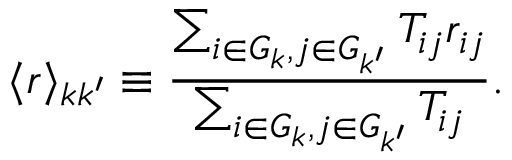Convert formula to latex. <formula><loc_0><loc_0><loc_500><loc_500>\langle r \rangle _ { k k ^ { \prime } } \equiv \frac { \sum _ { i \in G _ { k } , j \in G _ { k ^ { \prime } } } { T _ { i j } r _ { i j } } } { \sum _ { i \in G _ { k } , j \in G _ { k ^ { \prime } } } { T _ { i j } } } .</formula> 